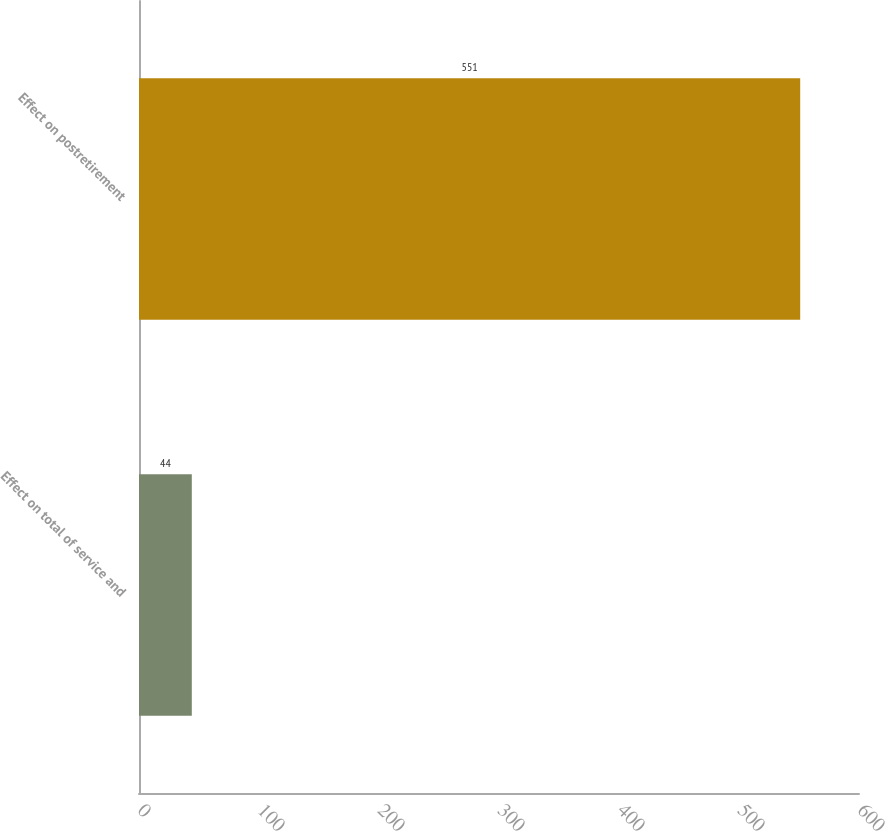Convert chart. <chart><loc_0><loc_0><loc_500><loc_500><bar_chart><fcel>Effect on total of service and<fcel>Effect on postretirement<nl><fcel>44<fcel>551<nl></chart> 